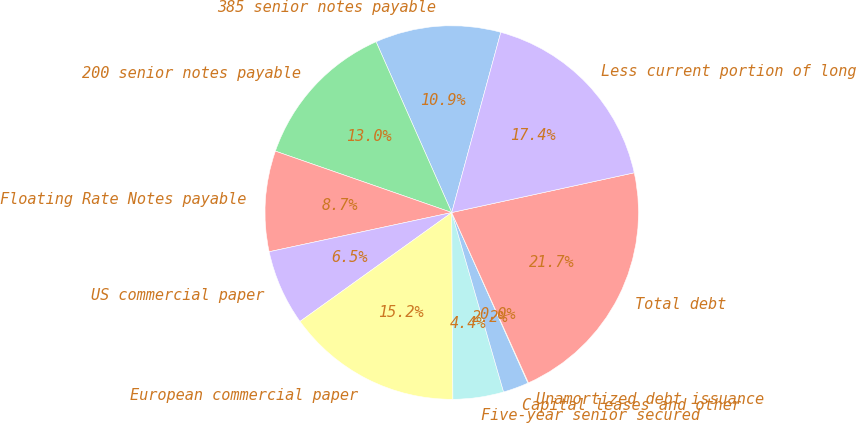Convert chart to OTSL. <chart><loc_0><loc_0><loc_500><loc_500><pie_chart><fcel>385 senior notes payable<fcel>200 senior notes payable<fcel>Floating Rate Notes payable<fcel>US commercial paper<fcel>European commercial paper<fcel>Five-year senior secured<fcel>Capital leases and other<fcel>Unamortized debt issuance<fcel>Total debt<fcel>Less current portion of long<nl><fcel>10.87%<fcel>13.03%<fcel>8.7%<fcel>6.54%<fcel>15.19%<fcel>4.38%<fcel>2.21%<fcel>0.05%<fcel>21.68%<fcel>17.36%<nl></chart> 